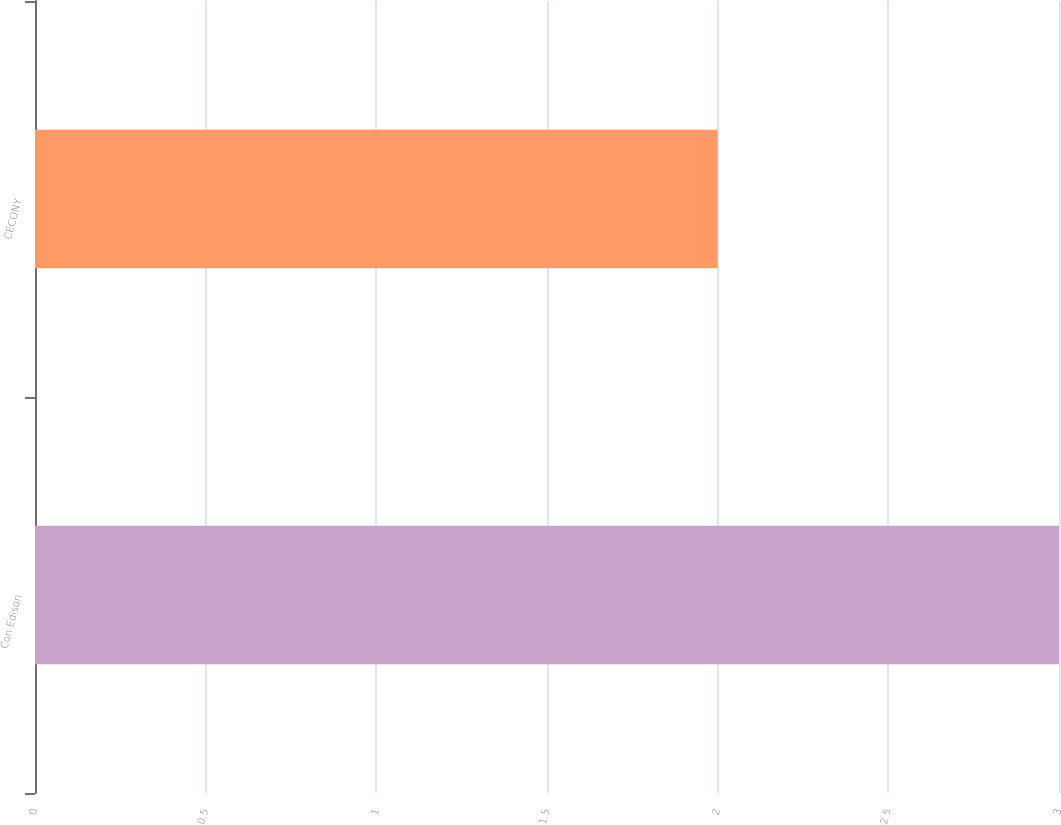<chart> <loc_0><loc_0><loc_500><loc_500><bar_chart><fcel>Con Edison<fcel>CECONY<nl><fcel>3<fcel>2<nl></chart> 